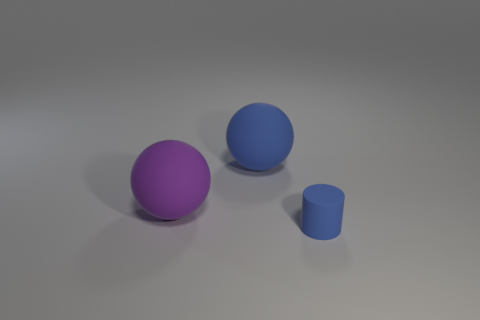What colors are the objects in the image? In the image, one object is purple, another is blue, and the smaller cylinder is also a shade of blue. Do the colors of these objects have any particular significance? Without additional context, the colors might not have a specific significance. They could be arbitrary or chosen for visual contrast in this composition. 